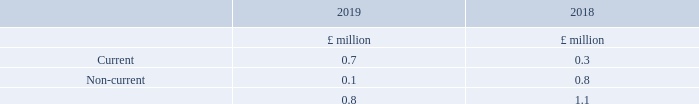12. Government grants
The following government grants are included within creditors:
A government grant has been received to accelerate and support research and development in the vulnerability of global navigation satellite systems.
What was the government grant received for? To accelerate and support research and development in the vulnerability of global navigation satellite systems. What was the amount of Current government grants in 2019?
Answer scale should be: million. 0.7. What are the types of government grants included within creditors? Current, non-current. In which year was the amount of current government grants larger? 0.7>0.3
Answer: 2019. What was the change in the amount of current government grants?
Answer scale should be: million. 0.7-0.3
Answer: 0.4. What was the percentage change in the amount of current government grants?
Answer scale should be: percent. (0.7-0.3)/0.3
Answer: 133.33. 